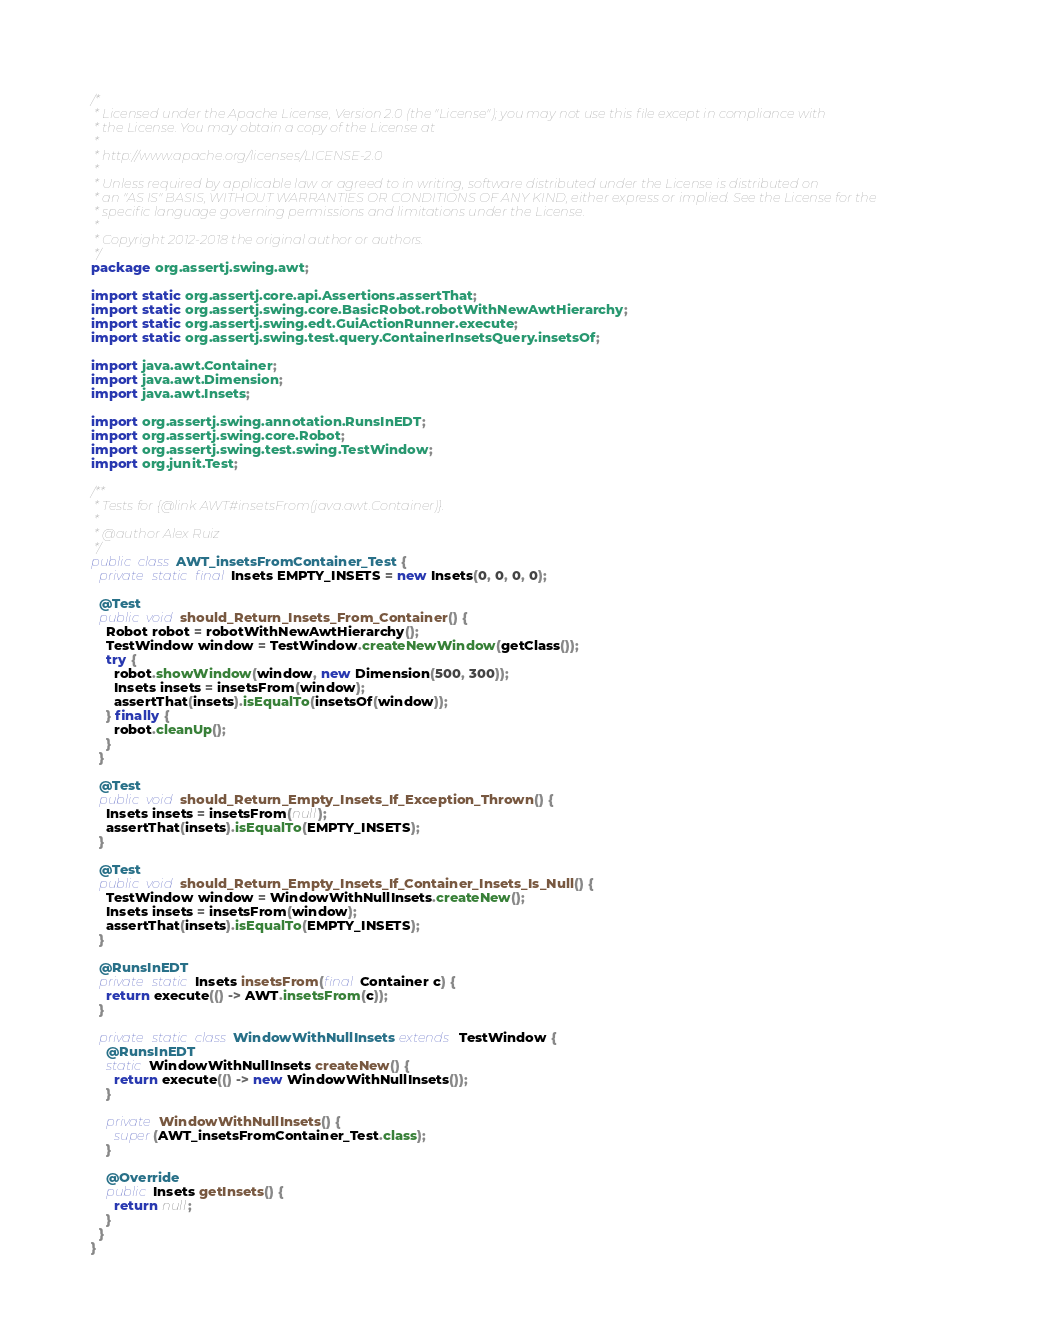<code> <loc_0><loc_0><loc_500><loc_500><_Java_>/*
 * Licensed under the Apache License, Version 2.0 (the "License"); you may not use this file except in compliance with
 * the License. You may obtain a copy of the License at
 *
 * http://www.apache.org/licenses/LICENSE-2.0
 *
 * Unless required by applicable law or agreed to in writing, software distributed under the License is distributed on
 * an "AS IS" BASIS, WITHOUT WARRANTIES OR CONDITIONS OF ANY KIND, either express or implied. See the License for the
 * specific language governing permissions and limitations under the License.
 *
 * Copyright 2012-2018 the original author or authors.
 */
package org.assertj.swing.awt;

import static org.assertj.core.api.Assertions.assertThat;
import static org.assertj.swing.core.BasicRobot.robotWithNewAwtHierarchy;
import static org.assertj.swing.edt.GuiActionRunner.execute;
import static org.assertj.swing.test.query.ContainerInsetsQuery.insetsOf;

import java.awt.Container;
import java.awt.Dimension;
import java.awt.Insets;

import org.assertj.swing.annotation.RunsInEDT;
import org.assertj.swing.core.Robot;
import org.assertj.swing.test.swing.TestWindow;
import org.junit.Test;

/**
 * Tests for {@link AWT#insetsFrom(java.awt.Container)}.
 *
 * @author Alex Ruiz
 */
public class AWT_insetsFromContainer_Test {
  private static final Insets EMPTY_INSETS = new Insets(0, 0, 0, 0);

  @Test
  public void should_Return_Insets_From_Container() {
    Robot robot = robotWithNewAwtHierarchy();
    TestWindow window = TestWindow.createNewWindow(getClass());
    try {
      robot.showWindow(window, new Dimension(500, 300));
      Insets insets = insetsFrom(window);
      assertThat(insets).isEqualTo(insetsOf(window));
    } finally {
      robot.cleanUp();
    }
  }

  @Test
  public void should_Return_Empty_Insets_If_Exception_Thrown() {
    Insets insets = insetsFrom(null);
    assertThat(insets).isEqualTo(EMPTY_INSETS);
  }

  @Test
  public void should_Return_Empty_Insets_If_Container_Insets_Is_Null() {
    TestWindow window = WindowWithNullInsets.createNew();
    Insets insets = insetsFrom(window);
    assertThat(insets).isEqualTo(EMPTY_INSETS);
  }

  @RunsInEDT
  private static Insets insetsFrom(final Container c) {
    return execute(() -> AWT.insetsFrom(c));
  }

  private static class WindowWithNullInsets extends TestWindow {
    @RunsInEDT
    static WindowWithNullInsets createNew() {
      return execute(() -> new WindowWithNullInsets());
    }

    private WindowWithNullInsets() {
      super(AWT_insetsFromContainer_Test.class);
    }

    @Override
    public Insets getInsets() {
      return null;
    }
  }
}
</code> 